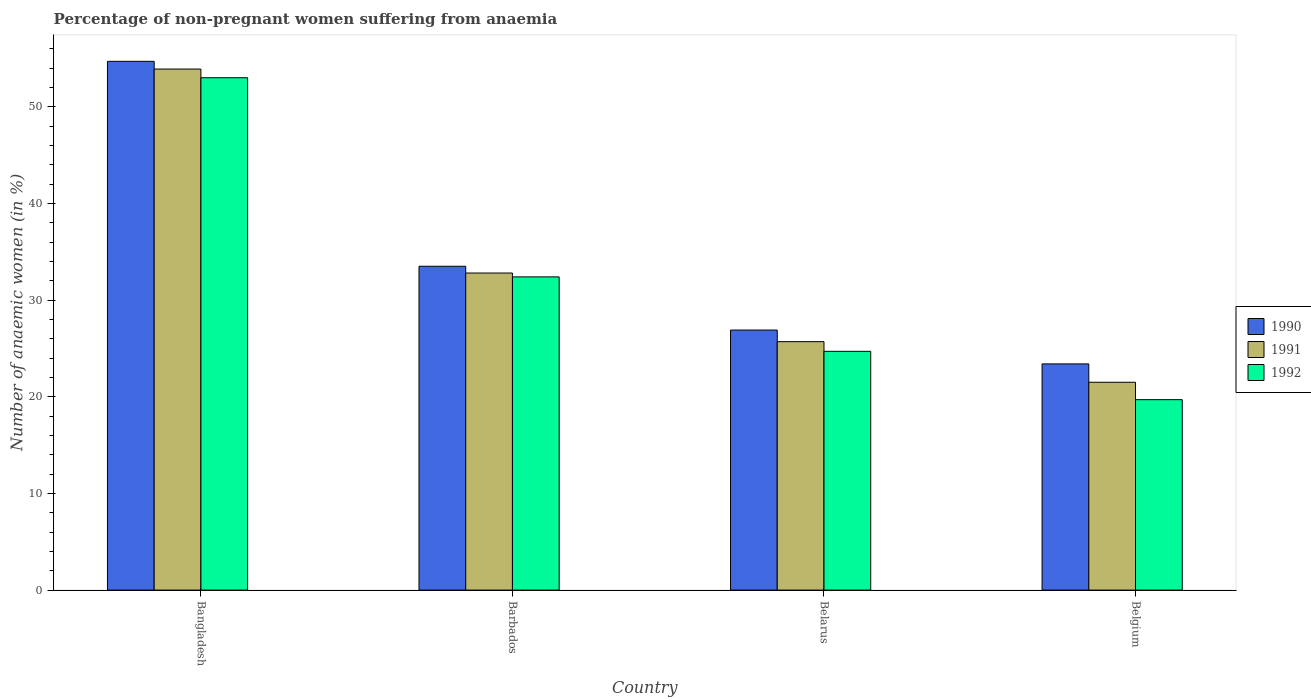How many different coloured bars are there?
Provide a short and direct response. 3. How many groups of bars are there?
Offer a terse response. 4. How many bars are there on the 2nd tick from the right?
Offer a very short reply. 3. What is the label of the 3rd group of bars from the left?
Provide a short and direct response. Belarus. In how many cases, is the number of bars for a given country not equal to the number of legend labels?
Offer a very short reply. 0. What is the percentage of non-pregnant women suffering from anaemia in 1990 in Belgium?
Your answer should be compact. 23.4. Across all countries, what is the maximum percentage of non-pregnant women suffering from anaemia in 1990?
Provide a succinct answer. 54.7. In which country was the percentage of non-pregnant women suffering from anaemia in 1992 maximum?
Offer a terse response. Bangladesh. What is the total percentage of non-pregnant women suffering from anaemia in 1990 in the graph?
Provide a short and direct response. 138.5. What is the difference between the percentage of non-pregnant women suffering from anaemia in 1990 in Bangladesh and that in Barbados?
Offer a very short reply. 21.2. What is the difference between the percentage of non-pregnant women suffering from anaemia in 1990 in Belarus and the percentage of non-pregnant women suffering from anaemia in 1991 in Bangladesh?
Keep it short and to the point. -27. What is the average percentage of non-pregnant women suffering from anaemia in 1990 per country?
Your answer should be compact. 34.62. What is the difference between the percentage of non-pregnant women suffering from anaemia of/in 1990 and percentage of non-pregnant women suffering from anaemia of/in 1991 in Barbados?
Offer a very short reply. 0.7. In how many countries, is the percentage of non-pregnant women suffering from anaemia in 1990 greater than 12 %?
Ensure brevity in your answer.  4. What is the ratio of the percentage of non-pregnant women suffering from anaemia in 1991 in Barbados to that in Belgium?
Offer a terse response. 1.53. Is the percentage of non-pregnant women suffering from anaemia in 1992 in Barbados less than that in Belgium?
Offer a terse response. No. What is the difference between the highest and the second highest percentage of non-pregnant women suffering from anaemia in 1990?
Keep it short and to the point. 6.6. What is the difference between the highest and the lowest percentage of non-pregnant women suffering from anaemia in 1992?
Offer a terse response. 33.3. In how many countries, is the percentage of non-pregnant women suffering from anaemia in 1990 greater than the average percentage of non-pregnant women suffering from anaemia in 1990 taken over all countries?
Your answer should be very brief. 1. What does the 3rd bar from the left in Bangladesh represents?
Offer a very short reply. 1992. What does the 3rd bar from the right in Belgium represents?
Provide a succinct answer. 1990. Is it the case that in every country, the sum of the percentage of non-pregnant women suffering from anaemia in 1991 and percentage of non-pregnant women suffering from anaemia in 1992 is greater than the percentage of non-pregnant women suffering from anaemia in 1990?
Provide a short and direct response. Yes. How many countries are there in the graph?
Give a very brief answer. 4. How are the legend labels stacked?
Offer a very short reply. Vertical. What is the title of the graph?
Make the answer very short. Percentage of non-pregnant women suffering from anaemia. Does "1972" appear as one of the legend labels in the graph?
Offer a terse response. No. What is the label or title of the X-axis?
Ensure brevity in your answer.  Country. What is the label or title of the Y-axis?
Offer a very short reply. Number of anaemic women (in %). What is the Number of anaemic women (in %) in 1990 in Bangladesh?
Your answer should be very brief. 54.7. What is the Number of anaemic women (in %) in 1991 in Bangladesh?
Ensure brevity in your answer.  53.9. What is the Number of anaemic women (in %) in 1990 in Barbados?
Make the answer very short. 33.5. What is the Number of anaemic women (in %) of 1991 in Barbados?
Provide a succinct answer. 32.8. What is the Number of anaemic women (in %) of 1992 in Barbados?
Your answer should be compact. 32.4. What is the Number of anaemic women (in %) in 1990 in Belarus?
Provide a succinct answer. 26.9. What is the Number of anaemic women (in %) of 1991 in Belarus?
Your response must be concise. 25.7. What is the Number of anaemic women (in %) in 1992 in Belarus?
Offer a very short reply. 24.7. What is the Number of anaemic women (in %) in 1990 in Belgium?
Ensure brevity in your answer.  23.4. What is the Number of anaemic women (in %) of 1992 in Belgium?
Make the answer very short. 19.7. Across all countries, what is the maximum Number of anaemic women (in %) of 1990?
Your response must be concise. 54.7. Across all countries, what is the maximum Number of anaemic women (in %) in 1991?
Make the answer very short. 53.9. Across all countries, what is the maximum Number of anaemic women (in %) in 1992?
Provide a succinct answer. 53. Across all countries, what is the minimum Number of anaemic women (in %) of 1990?
Give a very brief answer. 23.4. Across all countries, what is the minimum Number of anaemic women (in %) of 1992?
Provide a succinct answer. 19.7. What is the total Number of anaemic women (in %) in 1990 in the graph?
Provide a succinct answer. 138.5. What is the total Number of anaemic women (in %) of 1991 in the graph?
Give a very brief answer. 133.9. What is the total Number of anaemic women (in %) in 1992 in the graph?
Make the answer very short. 129.8. What is the difference between the Number of anaemic women (in %) in 1990 in Bangladesh and that in Barbados?
Ensure brevity in your answer.  21.2. What is the difference between the Number of anaemic women (in %) of 1991 in Bangladesh and that in Barbados?
Your answer should be very brief. 21.1. What is the difference between the Number of anaemic women (in %) of 1992 in Bangladesh and that in Barbados?
Offer a very short reply. 20.6. What is the difference between the Number of anaemic women (in %) in 1990 in Bangladesh and that in Belarus?
Provide a succinct answer. 27.8. What is the difference between the Number of anaemic women (in %) in 1991 in Bangladesh and that in Belarus?
Offer a very short reply. 28.2. What is the difference between the Number of anaemic women (in %) in 1992 in Bangladesh and that in Belarus?
Keep it short and to the point. 28.3. What is the difference between the Number of anaemic women (in %) of 1990 in Bangladesh and that in Belgium?
Offer a terse response. 31.3. What is the difference between the Number of anaemic women (in %) of 1991 in Bangladesh and that in Belgium?
Ensure brevity in your answer.  32.4. What is the difference between the Number of anaemic women (in %) of 1992 in Bangladesh and that in Belgium?
Offer a terse response. 33.3. What is the difference between the Number of anaemic women (in %) of 1990 in Barbados and that in Belgium?
Ensure brevity in your answer.  10.1. What is the difference between the Number of anaemic women (in %) of 1992 in Barbados and that in Belgium?
Give a very brief answer. 12.7. What is the difference between the Number of anaemic women (in %) of 1992 in Belarus and that in Belgium?
Offer a very short reply. 5. What is the difference between the Number of anaemic women (in %) of 1990 in Bangladesh and the Number of anaemic women (in %) of 1991 in Barbados?
Your answer should be very brief. 21.9. What is the difference between the Number of anaemic women (in %) in 1990 in Bangladesh and the Number of anaemic women (in %) in 1992 in Barbados?
Offer a terse response. 22.3. What is the difference between the Number of anaemic women (in %) in 1991 in Bangladesh and the Number of anaemic women (in %) in 1992 in Belarus?
Offer a very short reply. 29.2. What is the difference between the Number of anaemic women (in %) in 1990 in Bangladesh and the Number of anaemic women (in %) in 1991 in Belgium?
Give a very brief answer. 33.2. What is the difference between the Number of anaemic women (in %) of 1991 in Bangladesh and the Number of anaemic women (in %) of 1992 in Belgium?
Keep it short and to the point. 34.2. What is the difference between the Number of anaemic women (in %) of 1990 in Barbados and the Number of anaemic women (in %) of 1992 in Belarus?
Your response must be concise. 8.8. What is the difference between the Number of anaemic women (in %) in 1990 in Barbados and the Number of anaemic women (in %) in 1991 in Belgium?
Your answer should be compact. 12. What is the difference between the Number of anaemic women (in %) in 1991 in Barbados and the Number of anaemic women (in %) in 1992 in Belgium?
Provide a succinct answer. 13.1. What is the average Number of anaemic women (in %) of 1990 per country?
Your answer should be compact. 34.62. What is the average Number of anaemic women (in %) in 1991 per country?
Provide a short and direct response. 33.48. What is the average Number of anaemic women (in %) of 1992 per country?
Offer a terse response. 32.45. What is the difference between the Number of anaemic women (in %) in 1991 and Number of anaemic women (in %) in 1992 in Bangladesh?
Offer a very short reply. 0.9. What is the difference between the Number of anaemic women (in %) of 1990 and Number of anaemic women (in %) of 1991 in Belarus?
Your answer should be very brief. 1.2. What is the difference between the Number of anaemic women (in %) in 1990 and Number of anaemic women (in %) in 1992 in Belarus?
Provide a succinct answer. 2.2. What is the difference between the Number of anaemic women (in %) of 1990 and Number of anaemic women (in %) of 1991 in Belgium?
Provide a short and direct response. 1.9. What is the difference between the Number of anaemic women (in %) in 1991 and Number of anaemic women (in %) in 1992 in Belgium?
Keep it short and to the point. 1.8. What is the ratio of the Number of anaemic women (in %) of 1990 in Bangladesh to that in Barbados?
Give a very brief answer. 1.63. What is the ratio of the Number of anaemic women (in %) of 1991 in Bangladesh to that in Barbados?
Offer a terse response. 1.64. What is the ratio of the Number of anaemic women (in %) in 1992 in Bangladesh to that in Barbados?
Offer a terse response. 1.64. What is the ratio of the Number of anaemic women (in %) in 1990 in Bangladesh to that in Belarus?
Your response must be concise. 2.03. What is the ratio of the Number of anaemic women (in %) in 1991 in Bangladesh to that in Belarus?
Your answer should be very brief. 2.1. What is the ratio of the Number of anaemic women (in %) of 1992 in Bangladesh to that in Belarus?
Your response must be concise. 2.15. What is the ratio of the Number of anaemic women (in %) of 1990 in Bangladesh to that in Belgium?
Give a very brief answer. 2.34. What is the ratio of the Number of anaemic women (in %) in 1991 in Bangladesh to that in Belgium?
Keep it short and to the point. 2.51. What is the ratio of the Number of anaemic women (in %) in 1992 in Bangladesh to that in Belgium?
Your answer should be very brief. 2.69. What is the ratio of the Number of anaemic women (in %) in 1990 in Barbados to that in Belarus?
Make the answer very short. 1.25. What is the ratio of the Number of anaemic women (in %) of 1991 in Barbados to that in Belarus?
Your answer should be very brief. 1.28. What is the ratio of the Number of anaemic women (in %) of 1992 in Barbados to that in Belarus?
Give a very brief answer. 1.31. What is the ratio of the Number of anaemic women (in %) in 1990 in Barbados to that in Belgium?
Your response must be concise. 1.43. What is the ratio of the Number of anaemic women (in %) of 1991 in Barbados to that in Belgium?
Make the answer very short. 1.53. What is the ratio of the Number of anaemic women (in %) of 1992 in Barbados to that in Belgium?
Provide a succinct answer. 1.64. What is the ratio of the Number of anaemic women (in %) of 1990 in Belarus to that in Belgium?
Your response must be concise. 1.15. What is the ratio of the Number of anaemic women (in %) in 1991 in Belarus to that in Belgium?
Offer a terse response. 1.2. What is the ratio of the Number of anaemic women (in %) of 1992 in Belarus to that in Belgium?
Ensure brevity in your answer.  1.25. What is the difference between the highest and the second highest Number of anaemic women (in %) in 1990?
Ensure brevity in your answer.  21.2. What is the difference between the highest and the second highest Number of anaemic women (in %) of 1991?
Your answer should be compact. 21.1. What is the difference between the highest and the second highest Number of anaemic women (in %) of 1992?
Provide a short and direct response. 20.6. What is the difference between the highest and the lowest Number of anaemic women (in %) of 1990?
Offer a terse response. 31.3. What is the difference between the highest and the lowest Number of anaemic women (in %) in 1991?
Your answer should be very brief. 32.4. What is the difference between the highest and the lowest Number of anaemic women (in %) in 1992?
Provide a short and direct response. 33.3. 